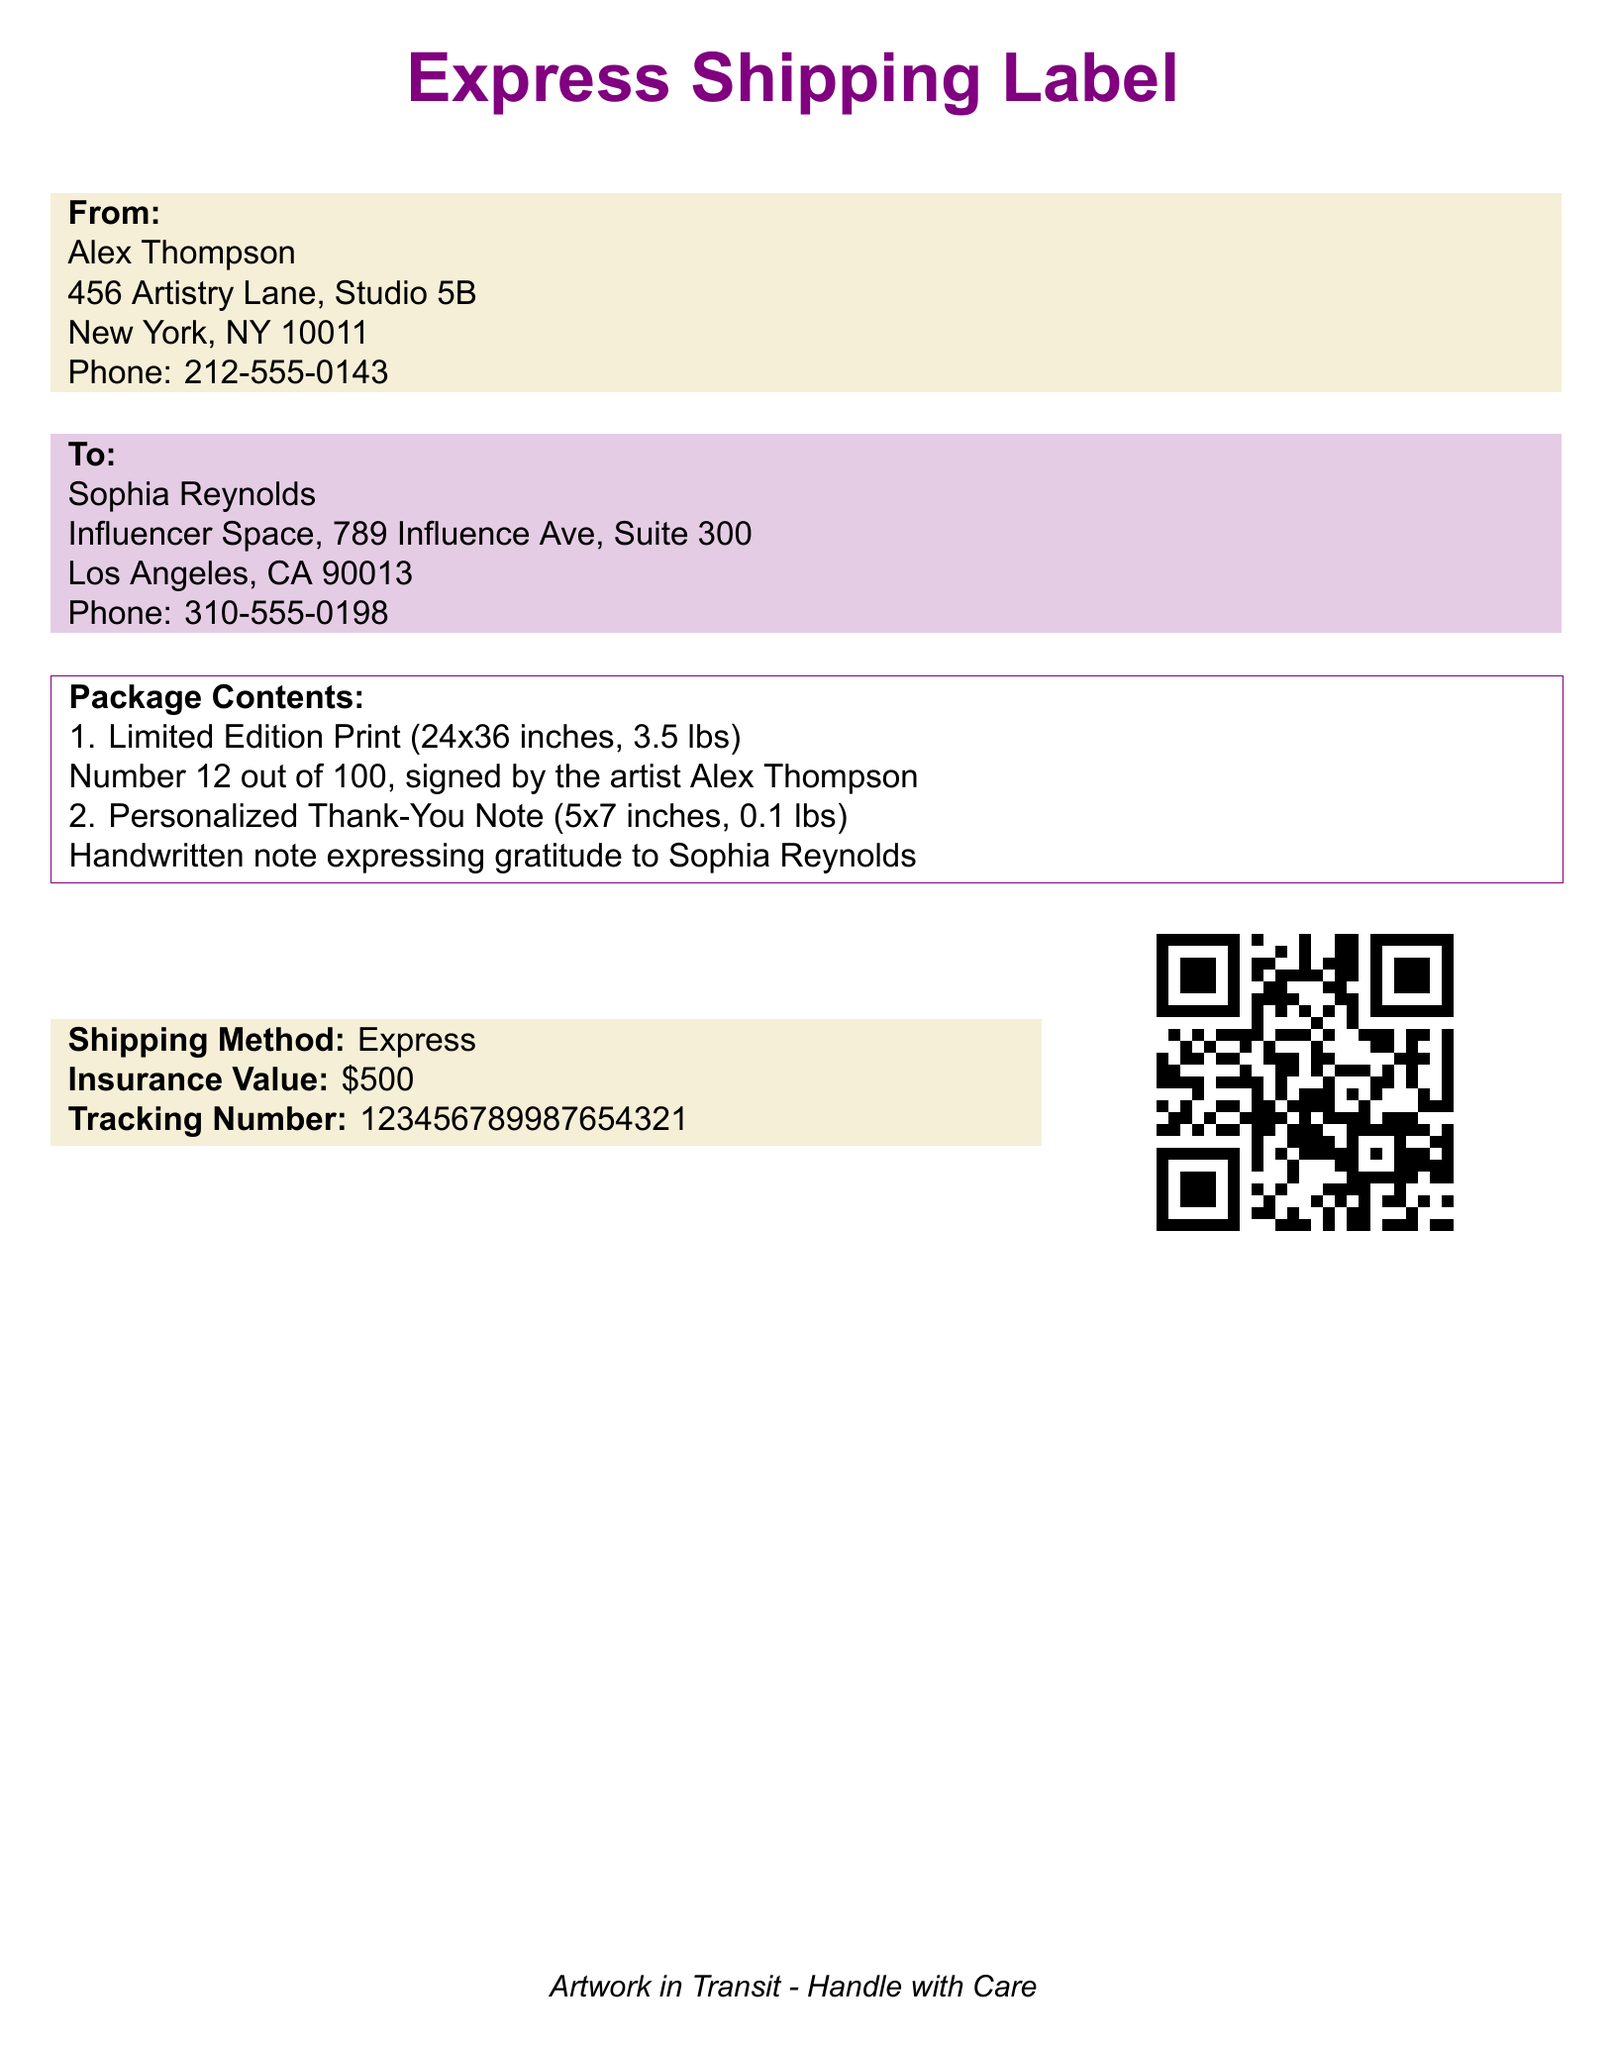What is the name of the artist? The name of the artist is mentioned in the document as Alex Thompson.
Answer: Alex Thompson What is the address of the recipient? The recipient's address is included in the document, which is located in Los Angeles, CA.
Answer: 789 Influence Ave, Suite 300, Los Angeles, CA 90013 How many prints are in the limited edition? The document states that the limited edition consists of 100 prints.
Answer: 100 What is the shipping method used? The shipping method is specified in the document as Express.
Answer: Express What is the weight of the limited edition print? The weight of the limited edition print is mentioned in the document as 3.5 lbs.
Answer: 3.5 lbs What is the tracking number of the shipment? The tracking number is provided in the document for tracking the shipment.
Answer: 123456789987654321 What is included with the limited edition print? The document details the contents of the package, which includes a personalized thank-you note.
Answer: Personalized Thank-You Note What number is the print of this limited edition? The document specifies that this print is Number 12 out of 100.
Answer: Number 12 What is the insurance value of the shipment? The document indicates the insurance value for the shipment as $500.
Answer: $500 